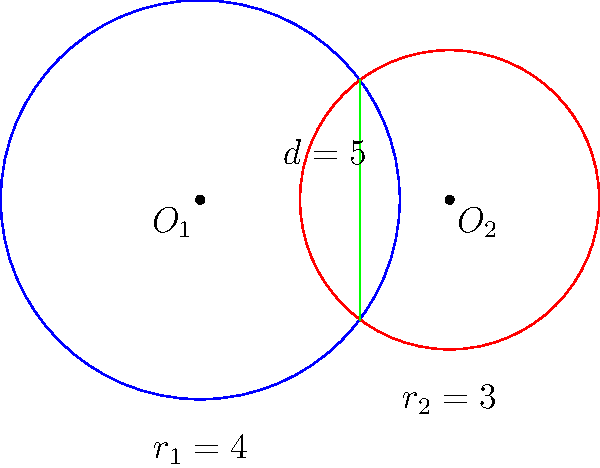In a strategic planning project for optimizing warehouse layouts, you encounter two circular storage areas that partially overlap. The centers of these storage areas are 5 units apart. The first storage area has a radius of 4 units, while the second has a radius of 3 units. Calculate the overlapping area to determine the shared storage space. Round your answer to two decimal places. Let's approach this step-by-step:

1) First, we need to calculate the distance between the centers of the circles to their intersection points. We can do this using the formula:

   $$a = \frac{r_1^2 - r_2^2 + d^2}{2d}$$

   Where $r_1 = 4$, $r_2 = 3$, and $d = 5$

2) Plugging in the values:

   $$a = \frac{4^2 - 3^2 + 5^2}{2(5)} = \frac{16 - 9 + 25}{10} = \frac{32}{10} = 3.2$$

3) Now we can calculate $b$ (the distance from the center of the second circle to the intersection points):

   $$b = d - a = 5 - 3.2 = 1.8$$

4) Next, we calculate the height of the triangle formed by the intersection points and the centers:

   $$h = \sqrt{r_1^2 - a^2} = \sqrt{4^2 - 3.2^2} = \sqrt{16 - 10.24} = \sqrt{5.76} = 2.4$$

5) The area of the overlapping region is the sum of two circular segments. The area of each segment is given by:

   $$A_{segment} = r^2 \arccos(\frac{x}{r}) - x\sqrt{r^2 - x^2}$$

   Where $x$ is the distance from the center to the chord (a or b in our case)

6) For the first circle:

   $$A_1 = 4^2 \arccos(\frac{3.2}{4}) - 3.2\sqrt{4^2 - 3.2^2} = 16 \arccos(0.8) - 3.2(2.4)$$

7) For the second circle:

   $$A_2 = 3^2 \arccos(\frac{1.8}{3}) - 1.8\sqrt{3^2 - 1.8^2} = 9 \arccos(0.6) - 1.8(2.4)$$

8) The total overlapping area is $A_1 + A_2$

9) Calculating and rounding to two decimal places:

   $$A_{total} = (16 \arccos(0.8) - 7.68) + (9 \arccos(0.6) - 4.32) = 8.69$$
Answer: 8.69 square units 